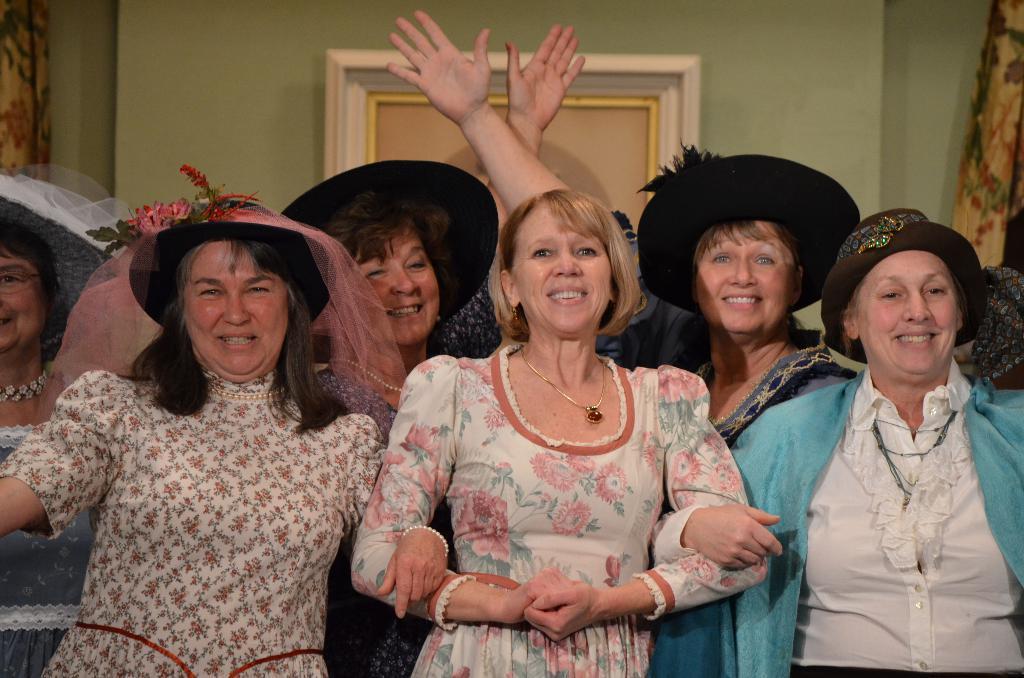In one or two sentences, can you explain what this image depicts? In this image there are group of people standing , and at the background there is curtain, frame attached to wall. 